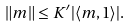Convert formula to latex. <formula><loc_0><loc_0><loc_500><loc_500>\| m \| \leq K ^ { \prime } | \langle m , 1 \rangle | .</formula> 